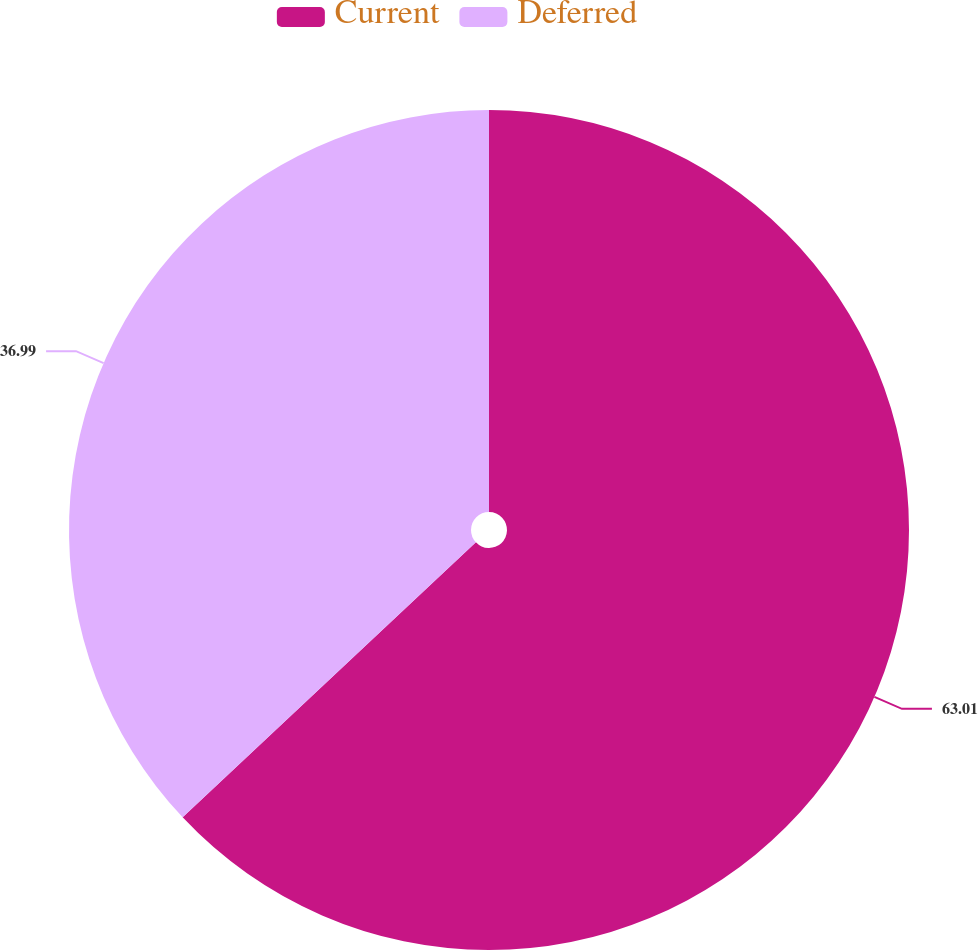Convert chart to OTSL. <chart><loc_0><loc_0><loc_500><loc_500><pie_chart><fcel>Current<fcel>Deferred<nl><fcel>63.01%<fcel>36.99%<nl></chart> 